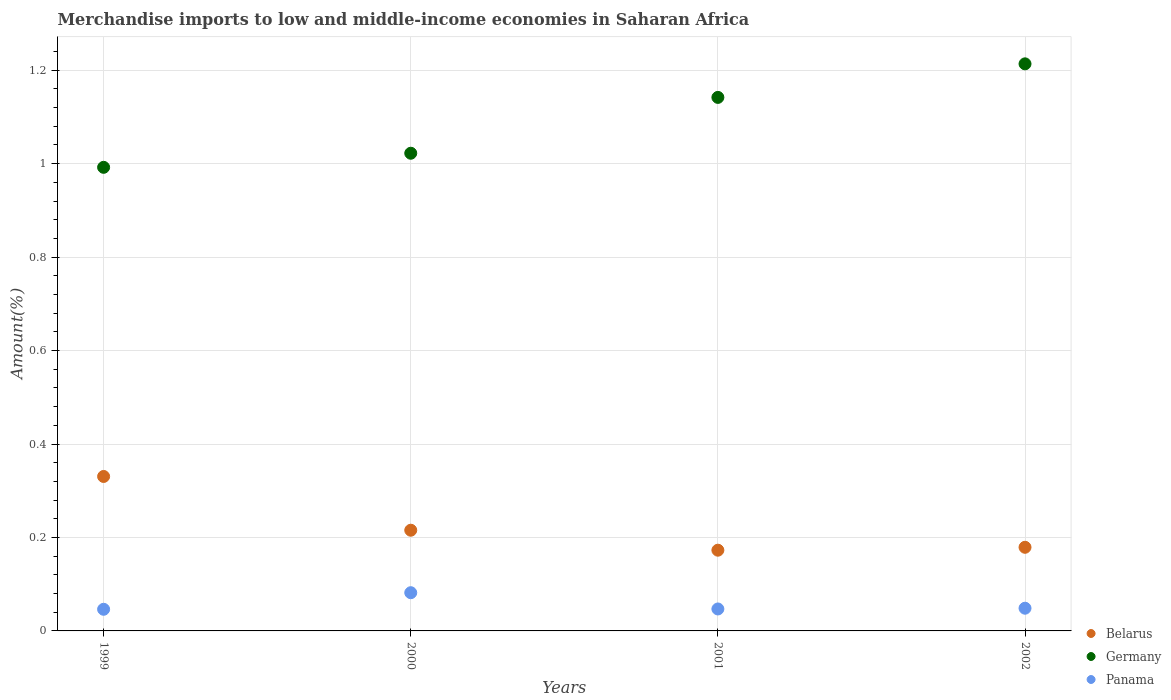Is the number of dotlines equal to the number of legend labels?
Ensure brevity in your answer.  Yes. What is the percentage of amount earned from merchandise imports in Belarus in 1999?
Give a very brief answer. 0.33. Across all years, what is the maximum percentage of amount earned from merchandise imports in Panama?
Ensure brevity in your answer.  0.08. Across all years, what is the minimum percentage of amount earned from merchandise imports in Belarus?
Give a very brief answer. 0.17. In which year was the percentage of amount earned from merchandise imports in Belarus minimum?
Offer a terse response. 2001. What is the total percentage of amount earned from merchandise imports in Germany in the graph?
Your answer should be very brief. 4.37. What is the difference between the percentage of amount earned from merchandise imports in Panama in 2001 and that in 2002?
Your response must be concise. -0. What is the difference between the percentage of amount earned from merchandise imports in Belarus in 1999 and the percentage of amount earned from merchandise imports in Germany in 2001?
Your response must be concise. -0.81. What is the average percentage of amount earned from merchandise imports in Panama per year?
Offer a terse response. 0.06. In the year 2000, what is the difference between the percentage of amount earned from merchandise imports in Panama and percentage of amount earned from merchandise imports in Germany?
Offer a very short reply. -0.94. What is the ratio of the percentage of amount earned from merchandise imports in Germany in 1999 to that in 2001?
Provide a short and direct response. 0.87. Is the percentage of amount earned from merchandise imports in Germany in 1999 less than that in 2001?
Provide a short and direct response. Yes. Is the difference between the percentage of amount earned from merchandise imports in Panama in 2000 and 2001 greater than the difference between the percentage of amount earned from merchandise imports in Germany in 2000 and 2001?
Make the answer very short. Yes. What is the difference between the highest and the second highest percentage of amount earned from merchandise imports in Belarus?
Your response must be concise. 0.12. What is the difference between the highest and the lowest percentage of amount earned from merchandise imports in Panama?
Provide a short and direct response. 0.04. In how many years, is the percentage of amount earned from merchandise imports in Panama greater than the average percentage of amount earned from merchandise imports in Panama taken over all years?
Make the answer very short. 1. Is the sum of the percentage of amount earned from merchandise imports in Panama in 2000 and 2002 greater than the maximum percentage of amount earned from merchandise imports in Germany across all years?
Provide a short and direct response. No. Does the percentage of amount earned from merchandise imports in Panama monotonically increase over the years?
Provide a succinct answer. No. Is the percentage of amount earned from merchandise imports in Panama strictly greater than the percentage of amount earned from merchandise imports in Belarus over the years?
Give a very brief answer. No. How many dotlines are there?
Your response must be concise. 3. How many years are there in the graph?
Offer a very short reply. 4. Where does the legend appear in the graph?
Provide a short and direct response. Bottom right. How many legend labels are there?
Keep it short and to the point. 3. How are the legend labels stacked?
Give a very brief answer. Vertical. What is the title of the graph?
Make the answer very short. Merchandise imports to low and middle-income economies in Saharan Africa. Does "Eritrea" appear as one of the legend labels in the graph?
Your answer should be compact. No. What is the label or title of the X-axis?
Keep it short and to the point. Years. What is the label or title of the Y-axis?
Ensure brevity in your answer.  Amount(%). What is the Amount(%) in Belarus in 1999?
Keep it short and to the point. 0.33. What is the Amount(%) of Germany in 1999?
Your answer should be very brief. 0.99. What is the Amount(%) in Panama in 1999?
Provide a short and direct response. 0.05. What is the Amount(%) in Belarus in 2000?
Keep it short and to the point. 0.22. What is the Amount(%) in Germany in 2000?
Keep it short and to the point. 1.02. What is the Amount(%) of Panama in 2000?
Offer a terse response. 0.08. What is the Amount(%) in Belarus in 2001?
Offer a terse response. 0.17. What is the Amount(%) in Germany in 2001?
Ensure brevity in your answer.  1.14. What is the Amount(%) in Panama in 2001?
Offer a terse response. 0.05. What is the Amount(%) in Belarus in 2002?
Make the answer very short. 0.18. What is the Amount(%) of Germany in 2002?
Offer a very short reply. 1.21. What is the Amount(%) of Panama in 2002?
Your response must be concise. 0.05. Across all years, what is the maximum Amount(%) in Belarus?
Make the answer very short. 0.33. Across all years, what is the maximum Amount(%) in Germany?
Offer a terse response. 1.21. Across all years, what is the maximum Amount(%) of Panama?
Your answer should be compact. 0.08. Across all years, what is the minimum Amount(%) in Belarus?
Make the answer very short. 0.17. Across all years, what is the minimum Amount(%) of Germany?
Ensure brevity in your answer.  0.99. Across all years, what is the minimum Amount(%) of Panama?
Your answer should be very brief. 0.05. What is the total Amount(%) in Belarus in the graph?
Offer a very short reply. 0.9. What is the total Amount(%) in Germany in the graph?
Provide a short and direct response. 4.37. What is the total Amount(%) in Panama in the graph?
Keep it short and to the point. 0.22. What is the difference between the Amount(%) of Belarus in 1999 and that in 2000?
Provide a short and direct response. 0.12. What is the difference between the Amount(%) in Germany in 1999 and that in 2000?
Offer a terse response. -0.03. What is the difference between the Amount(%) in Panama in 1999 and that in 2000?
Offer a very short reply. -0.04. What is the difference between the Amount(%) in Belarus in 1999 and that in 2001?
Your response must be concise. 0.16. What is the difference between the Amount(%) in Germany in 1999 and that in 2001?
Make the answer very short. -0.15. What is the difference between the Amount(%) in Panama in 1999 and that in 2001?
Offer a very short reply. -0. What is the difference between the Amount(%) of Belarus in 1999 and that in 2002?
Provide a succinct answer. 0.15. What is the difference between the Amount(%) in Germany in 1999 and that in 2002?
Ensure brevity in your answer.  -0.22. What is the difference between the Amount(%) in Panama in 1999 and that in 2002?
Provide a short and direct response. -0. What is the difference between the Amount(%) of Belarus in 2000 and that in 2001?
Your answer should be compact. 0.04. What is the difference between the Amount(%) in Germany in 2000 and that in 2001?
Your answer should be very brief. -0.12. What is the difference between the Amount(%) in Panama in 2000 and that in 2001?
Provide a succinct answer. 0.03. What is the difference between the Amount(%) of Belarus in 2000 and that in 2002?
Provide a short and direct response. 0.04. What is the difference between the Amount(%) in Germany in 2000 and that in 2002?
Offer a terse response. -0.19. What is the difference between the Amount(%) in Panama in 2000 and that in 2002?
Make the answer very short. 0.03. What is the difference between the Amount(%) in Belarus in 2001 and that in 2002?
Provide a short and direct response. -0.01. What is the difference between the Amount(%) in Germany in 2001 and that in 2002?
Offer a very short reply. -0.07. What is the difference between the Amount(%) in Panama in 2001 and that in 2002?
Offer a terse response. -0. What is the difference between the Amount(%) in Belarus in 1999 and the Amount(%) in Germany in 2000?
Keep it short and to the point. -0.69. What is the difference between the Amount(%) in Belarus in 1999 and the Amount(%) in Panama in 2000?
Provide a short and direct response. 0.25. What is the difference between the Amount(%) of Germany in 1999 and the Amount(%) of Panama in 2000?
Keep it short and to the point. 0.91. What is the difference between the Amount(%) of Belarus in 1999 and the Amount(%) of Germany in 2001?
Provide a succinct answer. -0.81. What is the difference between the Amount(%) of Belarus in 1999 and the Amount(%) of Panama in 2001?
Keep it short and to the point. 0.28. What is the difference between the Amount(%) in Germany in 1999 and the Amount(%) in Panama in 2001?
Your answer should be very brief. 0.95. What is the difference between the Amount(%) of Belarus in 1999 and the Amount(%) of Germany in 2002?
Offer a very short reply. -0.88. What is the difference between the Amount(%) of Belarus in 1999 and the Amount(%) of Panama in 2002?
Your answer should be very brief. 0.28. What is the difference between the Amount(%) in Germany in 1999 and the Amount(%) in Panama in 2002?
Offer a very short reply. 0.94. What is the difference between the Amount(%) of Belarus in 2000 and the Amount(%) of Germany in 2001?
Your response must be concise. -0.93. What is the difference between the Amount(%) of Belarus in 2000 and the Amount(%) of Panama in 2001?
Make the answer very short. 0.17. What is the difference between the Amount(%) in Germany in 2000 and the Amount(%) in Panama in 2001?
Your answer should be compact. 0.98. What is the difference between the Amount(%) in Belarus in 2000 and the Amount(%) in Germany in 2002?
Make the answer very short. -1. What is the difference between the Amount(%) in Belarus in 2000 and the Amount(%) in Panama in 2002?
Offer a terse response. 0.17. What is the difference between the Amount(%) of Germany in 2000 and the Amount(%) of Panama in 2002?
Ensure brevity in your answer.  0.97. What is the difference between the Amount(%) of Belarus in 2001 and the Amount(%) of Germany in 2002?
Provide a succinct answer. -1.04. What is the difference between the Amount(%) in Belarus in 2001 and the Amount(%) in Panama in 2002?
Provide a short and direct response. 0.12. What is the difference between the Amount(%) of Germany in 2001 and the Amount(%) of Panama in 2002?
Your answer should be compact. 1.09. What is the average Amount(%) in Belarus per year?
Your answer should be compact. 0.22. What is the average Amount(%) in Germany per year?
Make the answer very short. 1.09. What is the average Amount(%) of Panama per year?
Give a very brief answer. 0.06. In the year 1999, what is the difference between the Amount(%) of Belarus and Amount(%) of Germany?
Provide a succinct answer. -0.66. In the year 1999, what is the difference between the Amount(%) in Belarus and Amount(%) in Panama?
Offer a very short reply. 0.28. In the year 1999, what is the difference between the Amount(%) in Germany and Amount(%) in Panama?
Make the answer very short. 0.95. In the year 2000, what is the difference between the Amount(%) in Belarus and Amount(%) in Germany?
Your answer should be very brief. -0.81. In the year 2000, what is the difference between the Amount(%) of Belarus and Amount(%) of Panama?
Ensure brevity in your answer.  0.13. In the year 2000, what is the difference between the Amount(%) of Germany and Amount(%) of Panama?
Your answer should be very brief. 0.94. In the year 2001, what is the difference between the Amount(%) in Belarus and Amount(%) in Germany?
Your answer should be very brief. -0.97. In the year 2001, what is the difference between the Amount(%) in Belarus and Amount(%) in Panama?
Your response must be concise. 0.13. In the year 2001, what is the difference between the Amount(%) in Germany and Amount(%) in Panama?
Provide a succinct answer. 1.09. In the year 2002, what is the difference between the Amount(%) of Belarus and Amount(%) of Germany?
Give a very brief answer. -1.03. In the year 2002, what is the difference between the Amount(%) in Belarus and Amount(%) in Panama?
Offer a terse response. 0.13. In the year 2002, what is the difference between the Amount(%) of Germany and Amount(%) of Panama?
Your answer should be very brief. 1.16. What is the ratio of the Amount(%) in Belarus in 1999 to that in 2000?
Provide a succinct answer. 1.53. What is the ratio of the Amount(%) in Germany in 1999 to that in 2000?
Offer a very short reply. 0.97. What is the ratio of the Amount(%) in Panama in 1999 to that in 2000?
Ensure brevity in your answer.  0.57. What is the ratio of the Amount(%) of Belarus in 1999 to that in 2001?
Your response must be concise. 1.91. What is the ratio of the Amount(%) in Germany in 1999 to that in 2001?
Make the answer very short. 0.87. What is the ratio of the Amount(%) of Panama in 1999 to that in 2001?
Provide a succinct answer. 0.99. What is the ratio of the Amount(%) in Belarus in 1999 to that in 2002?
Offer a terse response. 1.85. What is the ratio of the Amount(%) of Germany in 1999 to that in 2002?
Your answer should be very brief. 0.82. What is the ratio of the Amount(%) of Panama in 1999 to that in 2002?
Ensure brevity in your answer.  0.95. What is the ratio of the Amount(%) of Belarus in 2000 to that in 2001?
Give a very brief answer. 1.25. What is the ratio of the Amount(%) of Germany in 2000 to that in 2001?
Your answer should be compact. 0.9. What is the ratio of the Amount(%) of Panama in 2000 to that in 2001?
Ensure brevity in your answer.  1.74. What is the ratio of the Amount(%) of Belarus in 2000 to that in 2002?
Your answer should be very brief. 1.2. What is the ratio of the Amount(%) in Germany in 2000 to that in 2002?
Keep it short and to the point. 0.84. What is the ratio of the Amount(%) of Panama in 2000 to that in 2002?
Make the answer very short. 1.68. What is the ratio of the Amount(%) in Belarus in 2001 to that in 2002?
Offer a very short reply. 0.97. What is the ratio of the Amount(%) of Germany in 2001 to that in 2002?
Make the answer very short. 0.94. What is the ratio of the Amount(%) of Panama in 2001 to that in 2002?
Give a very brief answer. 0.97. What is the difference between the highest and the second highest Amount(%) in Belarus?
Your response must be concise. 0.12. What is the difference between the highest and the second highest Amount(%) of Germany?
Provide a succinct answer. 0.07. What is the difference between the highest and the second highest Amount(%) in Panama?
Give a very brief answer. 0.03. What is the difference between the highest and the lowest Amount(%) in Belarus?
Make the answer very short. 0.16. What is the difference between the highest and the lowest Amount(%) in Germany?
Your answer should be very brief. 0.22. What is the difference between the highest and the lowest Amount(%) of Panama?
Offer a very short reply. 0.04. 